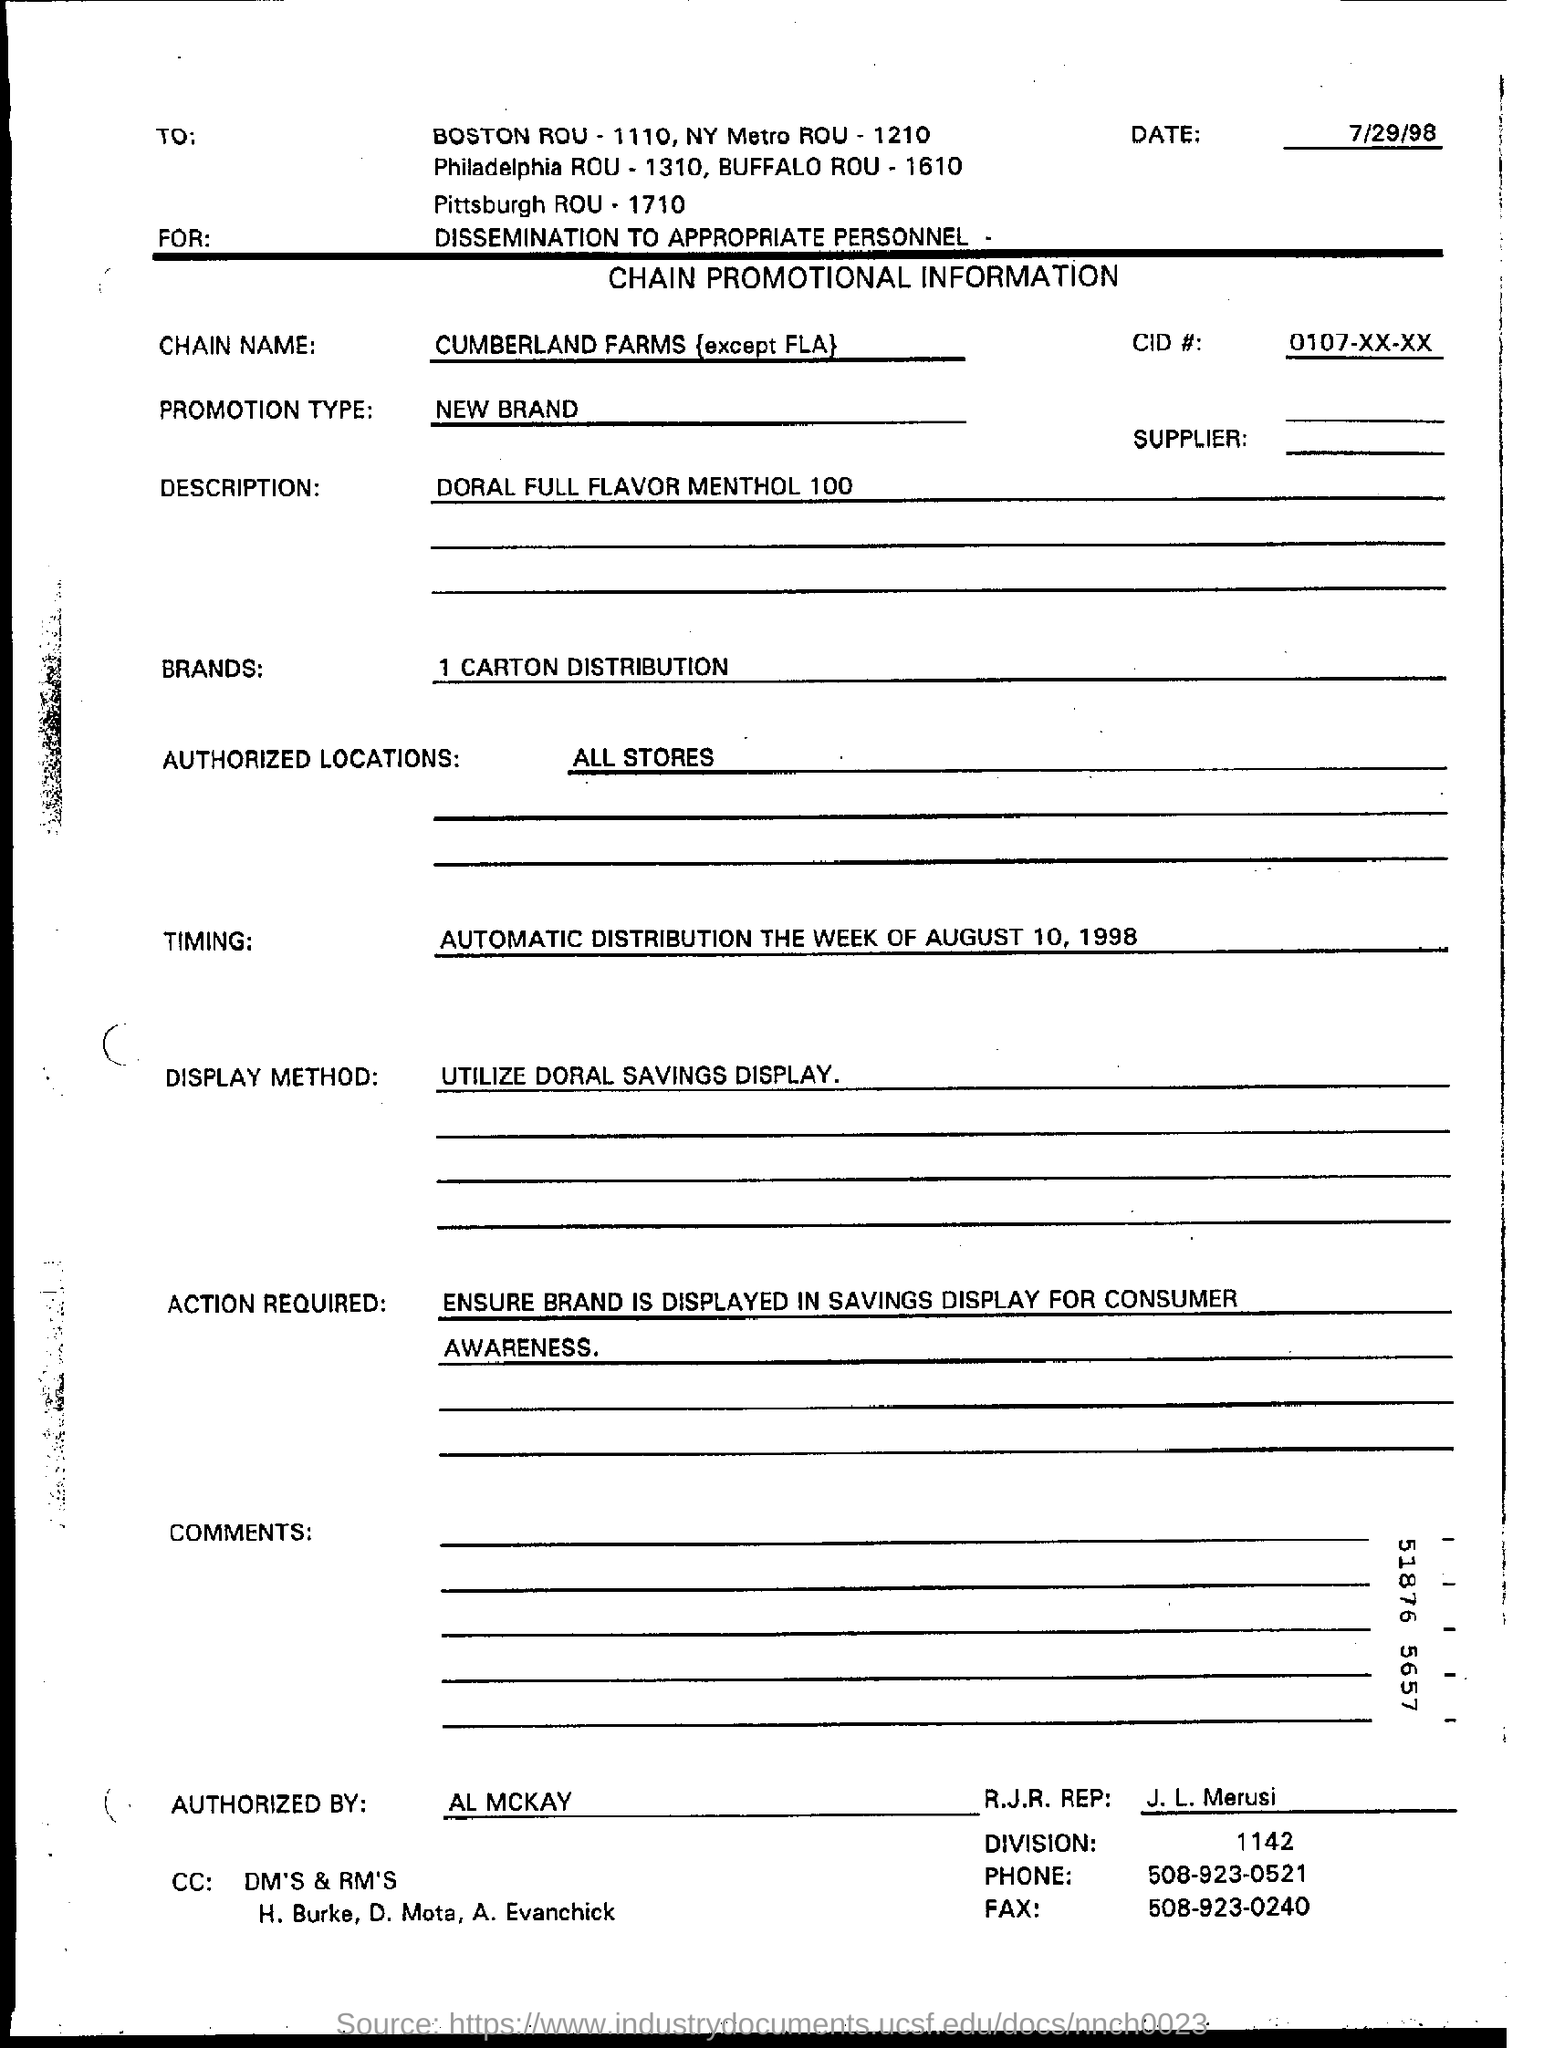Mention a couple of crucial points in this snapshot. All stores are authorized locations as mentioned on the form. The chain promotional information form was dated on July 29, 1998. In the presence of the undersigned, AL MCKAY declared that they authorized the form. 